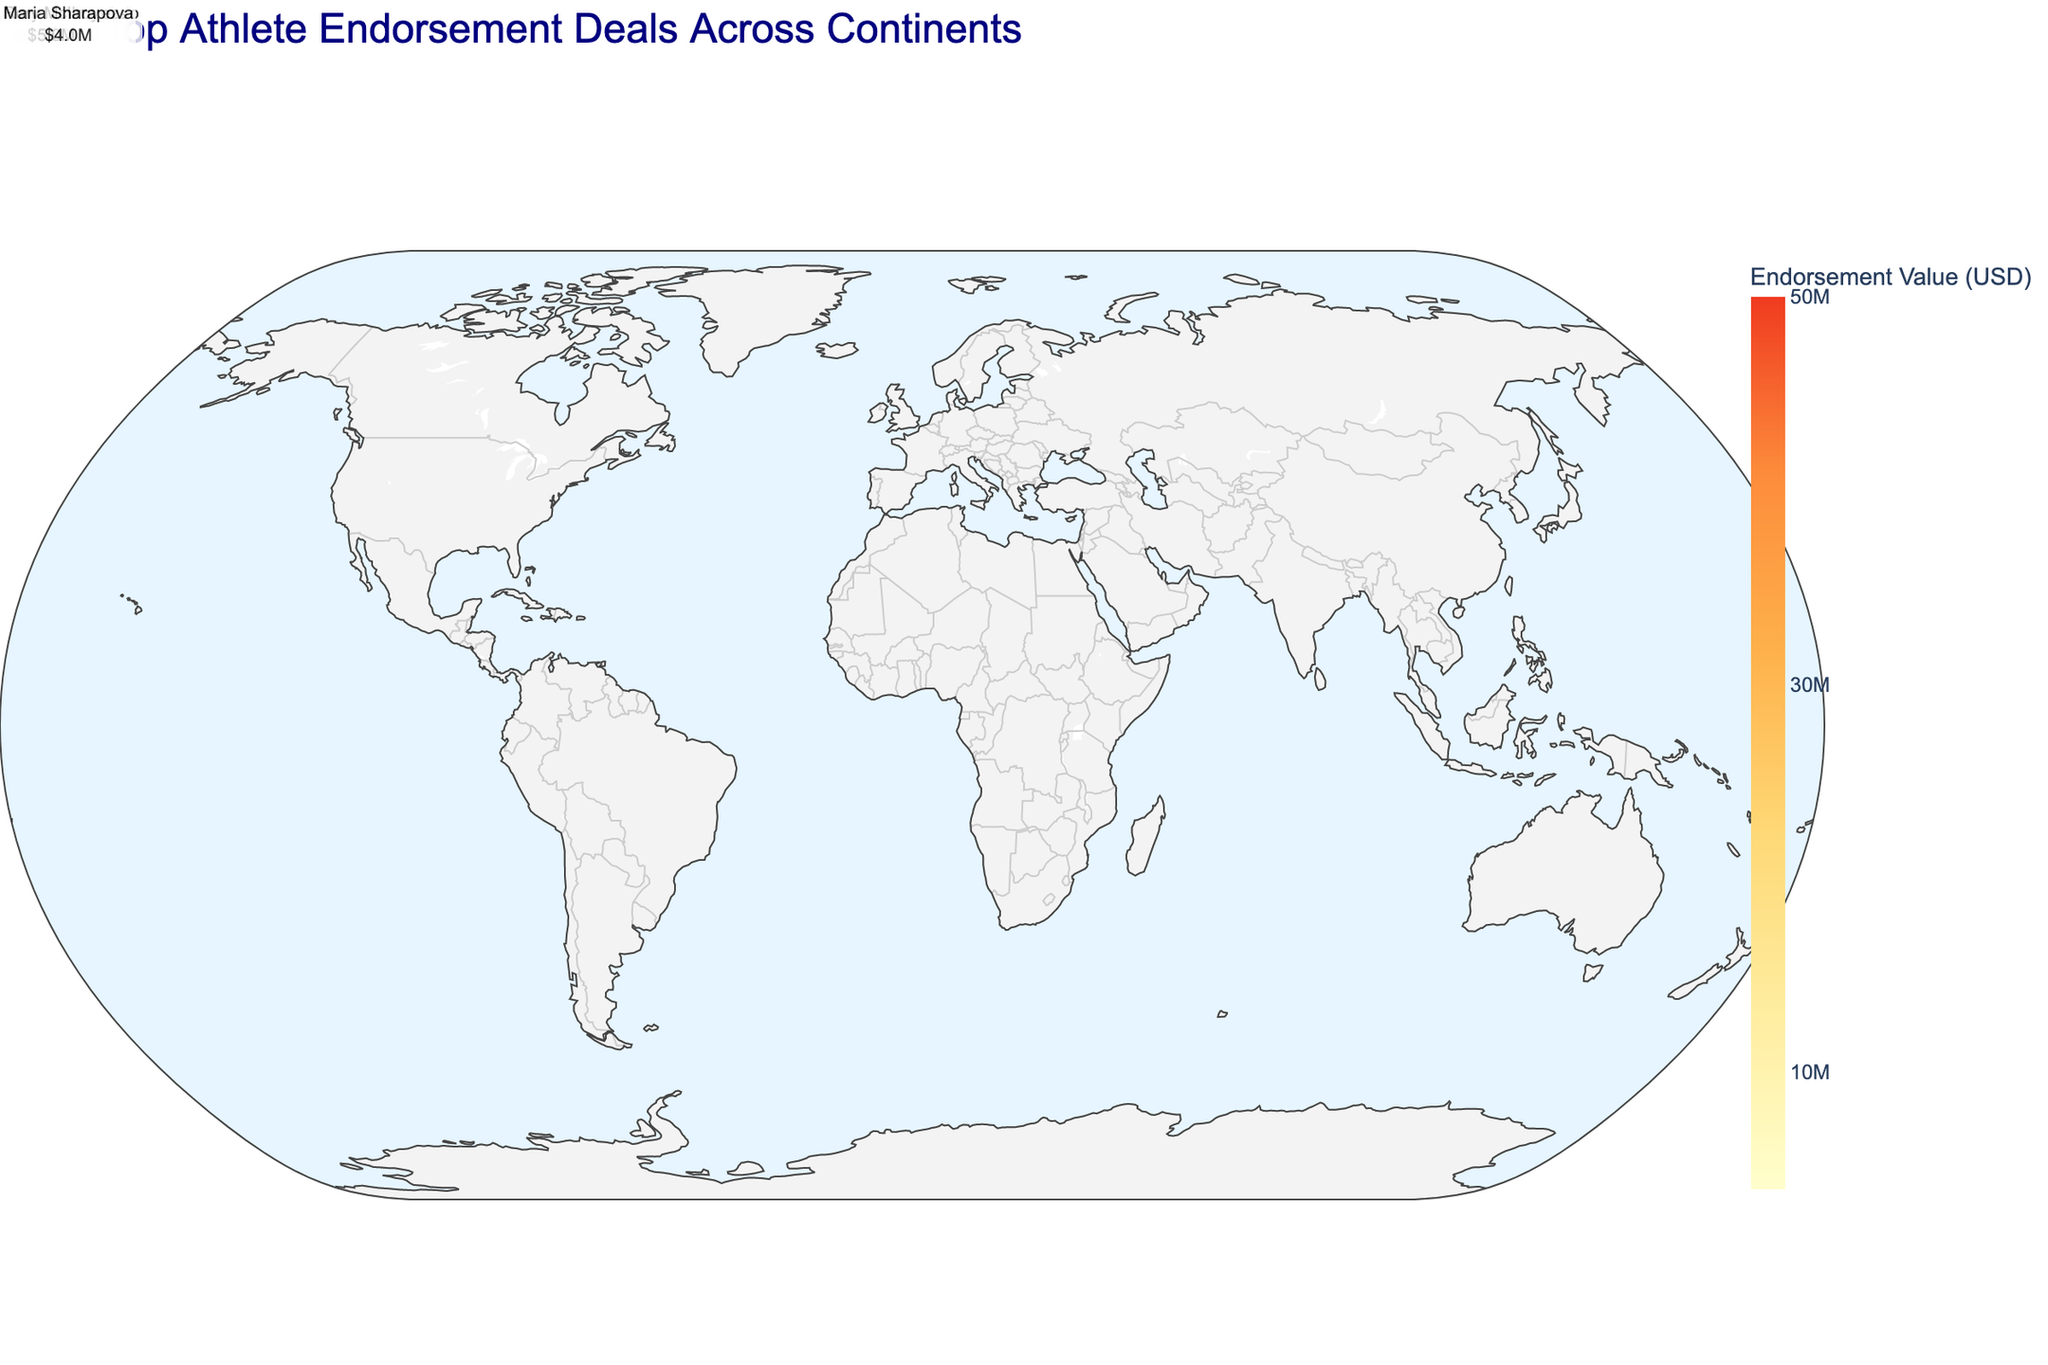Which athlete has the highest endorsement value? The figure shows the endorsement values of various athletes, and by observing the size of the points, it's clear that LeBron James has the largest point, indicating the highest endorsement value.
Answer: LeBron James What continent has the most athletes with high endorsement deals? By counting the number of data points associated with each continent, it's evident that Europe has the highest number of top athletes with significant endorsement deals.
Answer: Europe Which city in North America has the highest endorsement value? Looking at the data points on the map for North America, Los Angeles is associated with the highest endorsement value for LeBron James.
Answer: Los Angeles Who is the only athlete listed from South America and what sport do they play? The athlete from South America has their city marked in Rio de Janeiro, and hovering over the point, we see that it's Neymar Jr. from Soccer.
Answer: Neymar Jr., Soccer What is the total endorsement value for athletes in Europe? Summing up the endorsement values of athletes in Europe: Cristiano Ronaldo ($45M), Lionel Messi ($35M), Roger Federer ($20M), Lewis Hamilton ($10M), Rory McIlroy ($5M), and Maria Sharapova ($4M) results in a total value of $119M.
Answer: $119M Compare the endorsement values of Cristiano Ronaldo and Lionel Messi. Who has a higher value? Observing the size and hover data of the points for Cristiano Ronaldo and Lionel Messi, Cristiano Ronaldo has a higher endorsement value of $45M compared to Lionel Messi’s $35M.
Answer: Cristiano Ronaldo What is the endorsement value difference between Naomi Osaka and Serena Williams? By referring to the hover data for Naomi Osaka ($25M) and Serena Williams ($12M), the difference in endorsement value is calculated as $25M - $12M = $13M.
Answer: $13M Which city hosts multiple top athletes and who are they? By looking at the data points, Paris has multiple athletes: Lionel Messi and Kylian Mbappé.
Answer: Paris, Lionel Messi and Kylian Mbappé 